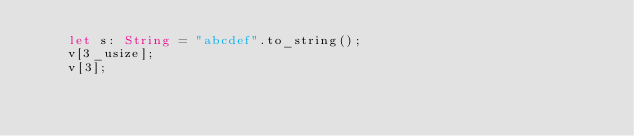Convert code to text. <code><loc_0><loc_0><loc_500><loc_500><_Rust_>    let s: String = "abcdef".to_string();
    v[3_usize];
    v[3];</code> 